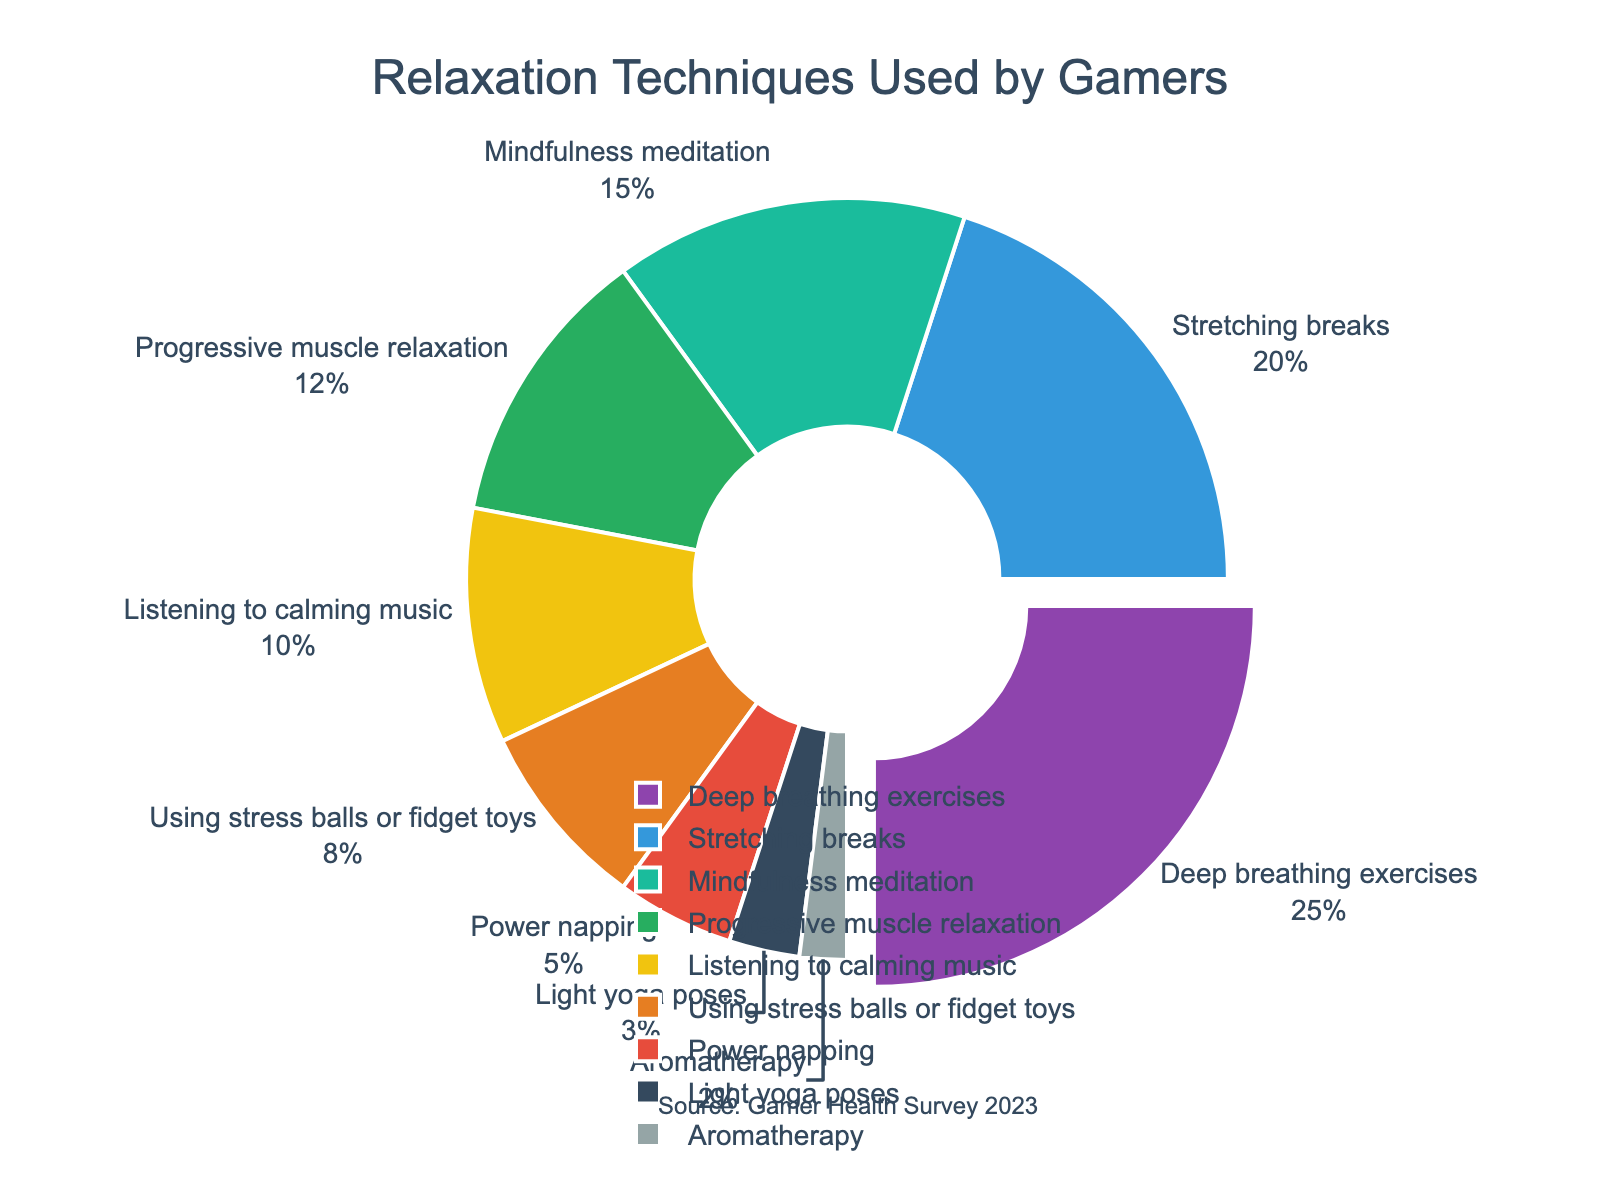What is the most popular relaxation technique used by gamers according to the pie chart? The dark purple slice is the largest, representing 25%, which is labeled as deep breathing exercises.
Answer: Deep breathing exercises How many techniques have more than 10% usage among gamers? The pie chart shows five techniques with more than 10% usage: deep breathing exercises (25%), stretching breaks (20%), mindfulness meditation (15%), progressive muscle relaxation (12%), and listening to calming music (10%).
Answer: 5 What is the combined percentage of gamers using power napping and light yoga poses as their relaxation techniques? The pie chart shows 5% for power napping and 3% for light yoga poses. Adding these together gives 5% + 3% = 8%.
Answer: 8% Which relaxation technique has the smallest percentage, and what is that percentage? The smallest slice is the light beige section, representing 2%, labeled as aromatherapy.
Answer: Aromatherapy, 2% What is the percentage difference between those who use progressive muscle relaxation and those who use stress balls or fidget toys? Progressive muscle relaxation is 12%, and stress balls or fidget toys are 8%. The difference is 12% - 8% = 4%.
Answer: 4% How does the popularity of listening to calming music compare with using stress balls or fidget toys? Listening to calming music has a higher percentage, with 10%, compared to using stress balls or fidget toys, which is 8%.
Answer: Listening to calming music is more popular What is the average percentage usage of the three least popular techniques? The three least popular techniques are light yoga poses (3%), aromatherapy (2%), and power napping (5%). Their combined percentage is 3% + 2% + 5% = 10%, and the average is 10% / 3 = 3.33%.
Answer: 3.33% What can you say about the distribution of relaxation techniques among gamers based on the color of the slices? The color distribution helps in visually distinguishing the techniques. The most popular technique (deep breathing exercises) stands out due to its dark purple color and larger size, while less popular techniques like aromatherapy (light beige) barely show due to their smaller size.
Answer: Varied colors show the popularity hierarchy How many techniques have less than 10% usage among gamers? The techniques with less than 10% usage are using stress balls or fidget toys (8%), power napping (5%), light yoga poses (3%), and aromatherapy (2%), making a total of four techniques.
Answer: 4 What is the combined percentage of mindfulness meditation and stretching breaks among gamers? Mindfulness meditation has 15% and stretching breaks have 20%. Adding them gives 15% + 20% = 35%.
Answer: 35% 